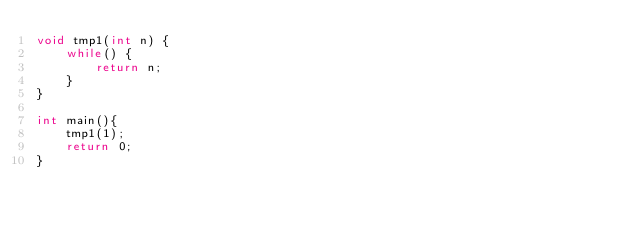Convert code to text. <code><loc_0><loc_0><loc_500><loc_500><_C++_>void tmp1(int n) {
    while() {
        return n;
    }
}

int main(){
    tmp1(1);
    return 0;
}</code> 